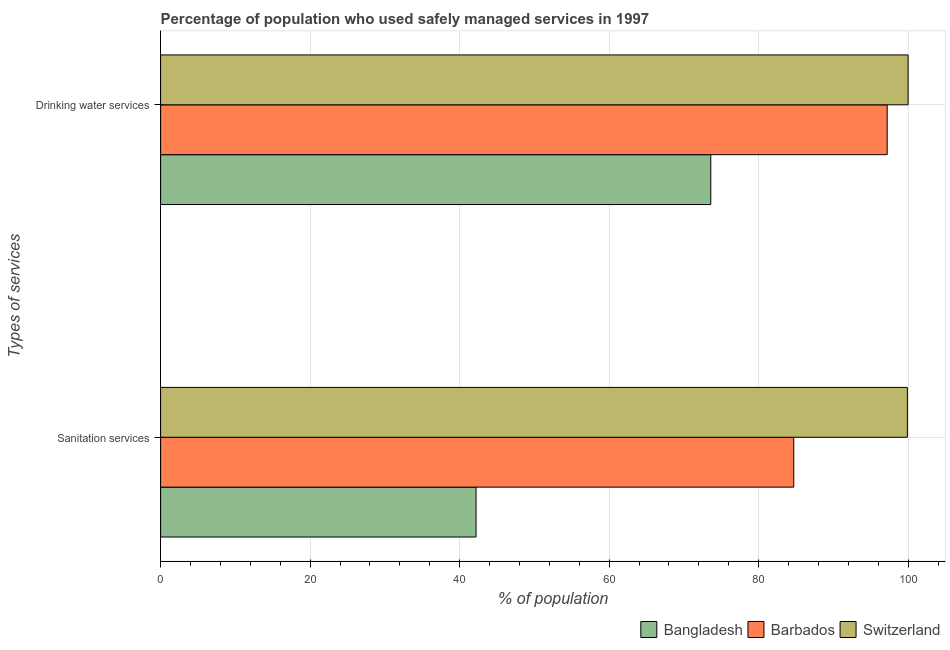How many different coloured bars are there?
Provide a succinct answer. 3. Are the number of bars per tick equal to the number of legend labels?
Your answer should be very brief. Yes. How many bars are there on the 1st tick from the top?
Provide a succinct answer. 3. How many bars are there on the 2nd tick from the bottom?
Your answer should be very brief. 3. What is the label of the 1st group of bars from the top?
Provide a short and direct response. Drinking water services. What is the percentage of population who used drinking water services in Switzerland?
Give a very brief answer. 100. Across all countries, what is the maximum percentage of population who used sanitation services?
Keep it short and to the point. 99.9. Across all countries, what is the minimum percentage of population who used drinking water services?
Offer a terse response. 73.6. In which country was the percentage of population who used sanitation services maximum?
Your response must be concise. Switzerland. In which country was the percentage of population who used drinking water services minimum?
Offer a very short reply. Bangladesh. What is the total percentage of population who used drinking water services in the graph?
Make the answer very short. 270.8. What is the difference between the percentage of population who used drinking water services in Switzerland and that in Bangladesh?
Keep it short and to the point. 26.4. What is the difference between the percentage of population who used sanitation services in Barbados and the percentage of population who used drinking water services in Switzerland?
Provide a short and direct response. -15.3. What is the average percentage of population who used drinking water services per country?
Provide a succinct answer. 90.27. What is the difference between the percentage of population who used sanitation services and percentage of population who used drinking water services in Switzerland?
Make the answer very short. -0.1. In how many countries, is the percentage of population who used drinking water services greater than 68 %?
Your answer should be very brief. 3. What is the ratio of the percentage of population who used drinking water services in Switzerland to that in Barbados?
Your answer should be very brief. 1.03. In how many countries, is the percentage of population who used drinking water services greater than the average percentage of population who used drinking water services taken over all countries?
Provide a short and direct response. 2. What does the 2nd bar from the top in Sanitation services represents?
Provide a short and direct response. Barbados. What does the 2nd bar from the bottom in Sanitation services represents?
Ensure brevity in your answer.  Barbados. What is the difference between two consecutive major ticks on the X-axis?
Provide a short and direct response. 20. Are the values on the major ticks of X-axis written in scientific E-notation?
Make the answer very short. No. Does the graph contain grids?
Offer a very short reply. Yes. Where does the legend appear in the graph?
Offer a very short reply. Bottom right. How many legend labels are there?
Your response must be concise. 3. What is the title of the graph?
Offer a very short reply. Percentage of population who used safely managed services in 1997. What is the label or title of the X-axis?
Provide a succinct answer. % of population. What is the label or title of the Y-axis?
Keep it short and to the point. Types of services. What is the % of population in Bangladesh in Sanitation services?
Give a very brief answer. 42.2. What is the % of population of Barbados in Sanitation services?
Offer a very short reply. 84.7. What is the % of population in Switzerland in Sanitation services?
Offer a terse response. 99.9. What is the % of population in Bangladesh in Drinking water services?
Ensure brevity in your answer.  73.6. What is the % of population of Barbados in Drinking water services?
Your answer should be very brief. 97.2. Across all Types of services, what is the maximum % of population in Bangladesh?
Provide a succinct answer. 73.6. Across all Types of services, what is the maximum % of population of Barbados?
Ensure brevity in your answer.  97.2. Across all Types of services, what is the maximum % of population of Switzerland?
Give a very brief answer. 100. Across all Types of services, what is the minimum % of population of Bangladesh?
Your response must be concise. 42.2. Across all Types of services, what is the minimum % of population of Barbados?
Keep it short and to the point. 84.7. Across all Types of services, what is the minimum % of population of Switzerland?
Provide a succinct answer. 99.9. What is the total % of population of Bangladesh in the graph?
Provide a succinct answer. 115.8. What is the total % of population of Barbados in the graph?
Keep it short and to the point. 181.9. What is the total % of population of Switzerland in the graph?
Your response must be concise. 199.9. What is the difference between the % of population in Bangladesh in Sanitation services and that in Drinking water services?
Give a very brief answer. -31.4. What is the difference between the % of population of Bangladesh in Sanitation services and the % of population of Barbados in Drinking water services?
Offer a very short reply. -55. What is the difference between the % of population in Bangladesh in Sanitation services and the % of population in Switzerland in Drinking water services?
Ensure brevity in your answer.  -57.8. What is the difference between the % of population of Barbados in Sanitation services and the % of population of Switzerland in Drinking water services?
Provide a short and direct response. -15.3. What is the average % of population of Bangladesh per Types of services?
Give a very brief answer. 57.9. What is the average % of population of Barbados per Types of services?
Your answer should be very brief. 90.95. What is the average % of population in Switzerland per Types of services?
Your answer should be very brief. 99.95. What is the difference between the % of population of Bangladesh and % of population of Barbados in Sanitation services?
Provide a short and direct response. -42.5. What is the difference between the % of population in Bangladesh and % of population in Switzerland in Sanitation services?
Keep it short and to the point. -57.7. What is the difference between the % of population of Barbados and % of population of Switzerland in Sanitation services?
Your answer should be very brief. -15.2. What is the difference between the % of population of Bangladesh and % of population of Barbados in Drinking water services?
Offer a terse response. -23.6. What is the difference between the % of population of Bangladesh and % of population of Switzerland in Drinking water services?
Give a very brief answer. -26.4. What is the difference between the % of population in Barbados and % of population in Switzerland in Drinking water services?
Your response must be concise. -2.8. What is the ratio of the % of population of Bangladesh in Sanitation services to that in Drinking water services?
Give a very brief answer. 0.57. What is the ratio of the % of population of Barbados in Sanitation services to that in Drinking water services?
Provide a succinct answer. 0.87. What is the difference between the highest and the second highest % of population of Bangladesh?
Your answer should be very brief. 31.4. What is the difference between the highest and the second highest % of population in Switzerland?
Your response must be concise. 0.1. What is the difference between the highest and the lowest % of population of Bangladesh?
Offer a very short reply. 31.4. 